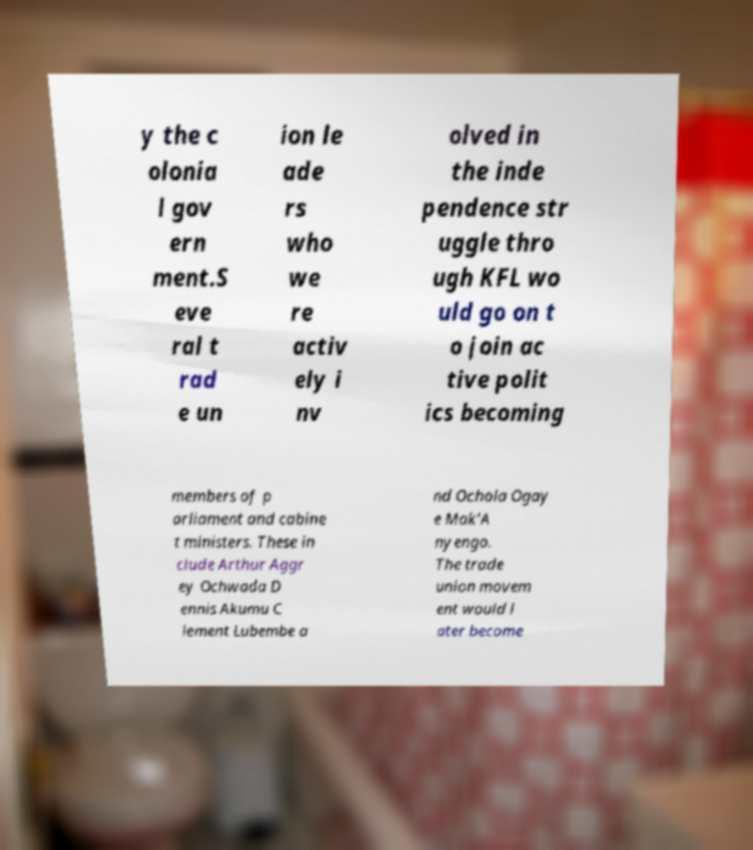Please read and relay the text visible in this image. What does it say? y the c olonia l gov ern ment.S eve ral t rad e un ion le ade rs who we re activ ely i nv olved in the inde pendence str uggle thro ugh KFL wo uld go on t o join ac tive polit ics becoming members of p arliament and cabine t ministers. These in clude Arthur Aggr ey Ochwada D ennis Akumu C lement Lubembe a nd Ochola Ogay e Mak'A nyengo. The trade union movem ent would l ater become 